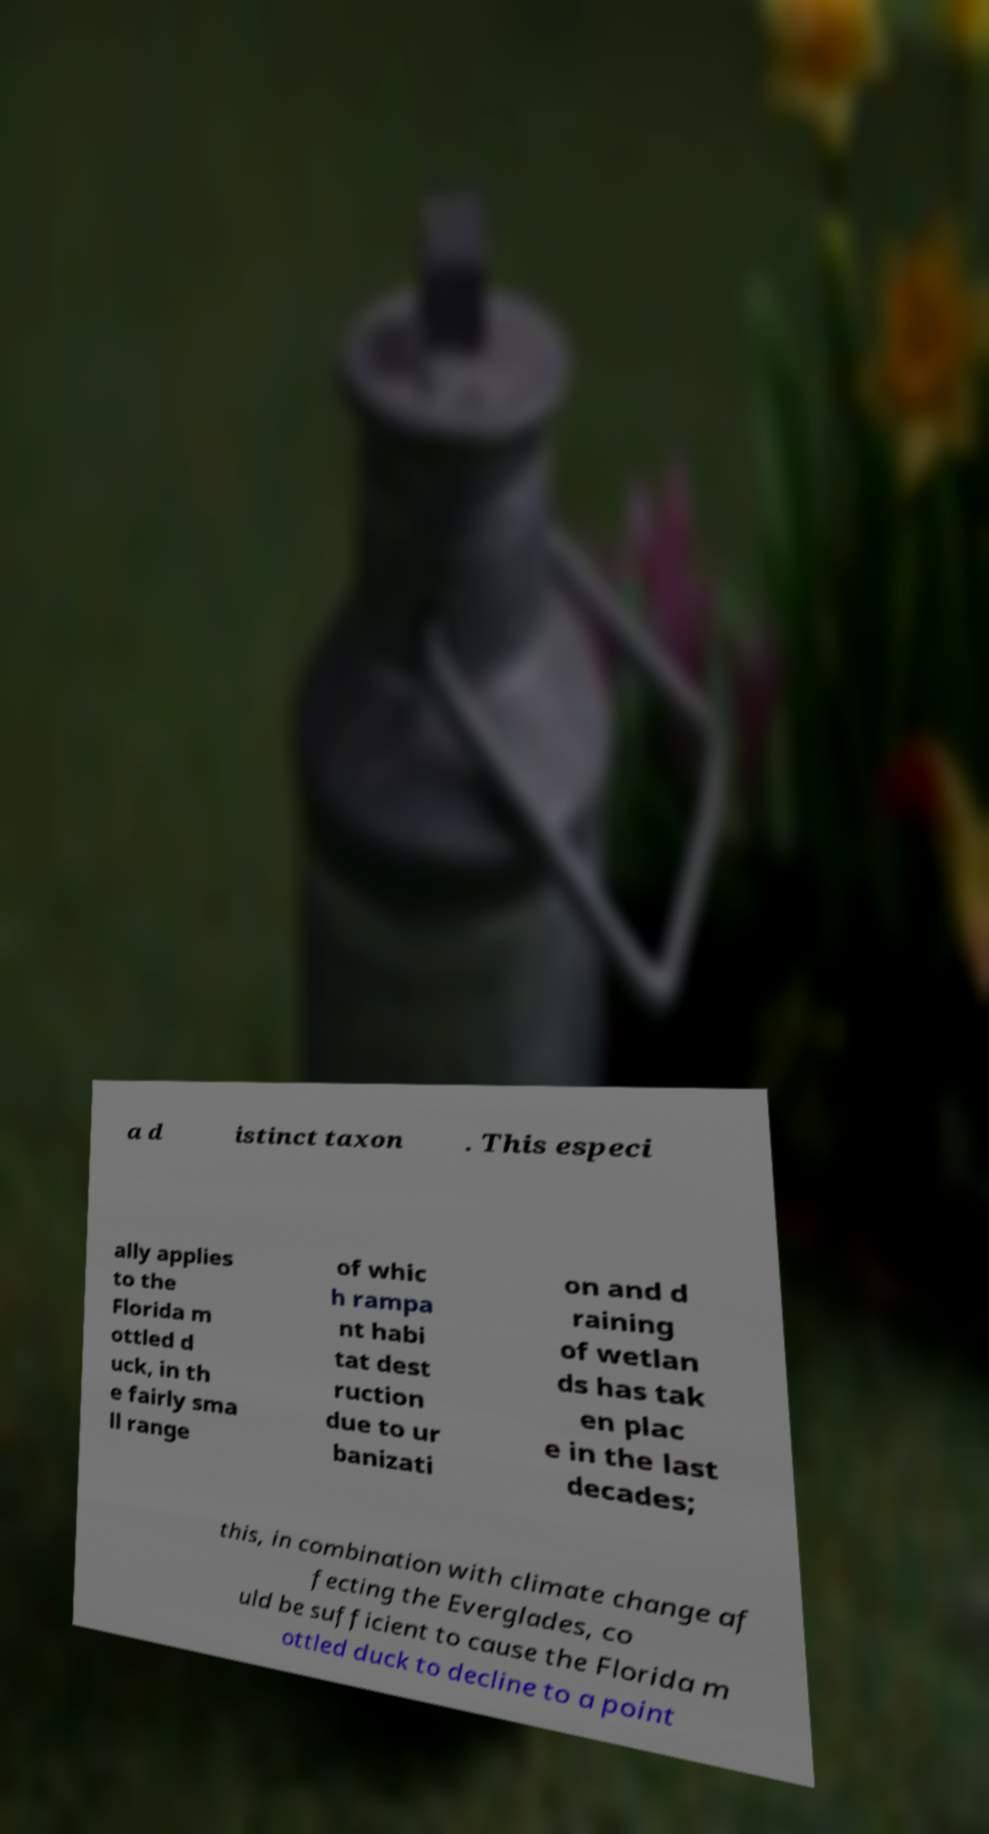Could you assist in decoding the text presented in this image and type it out clearly? a d istinct taxon . This especi ally applies to the Florida m ottled d uck, in th e fairly sma ll range of whic h rampa nt habi tat dest ruction due to ur banizati on and d raining of wetlan ds has tak en plac e in the last decades; this, in combination with climate change af fecting the Everglades, co uld be sufficient to cause the Florida m ottled duck to decline to a point 